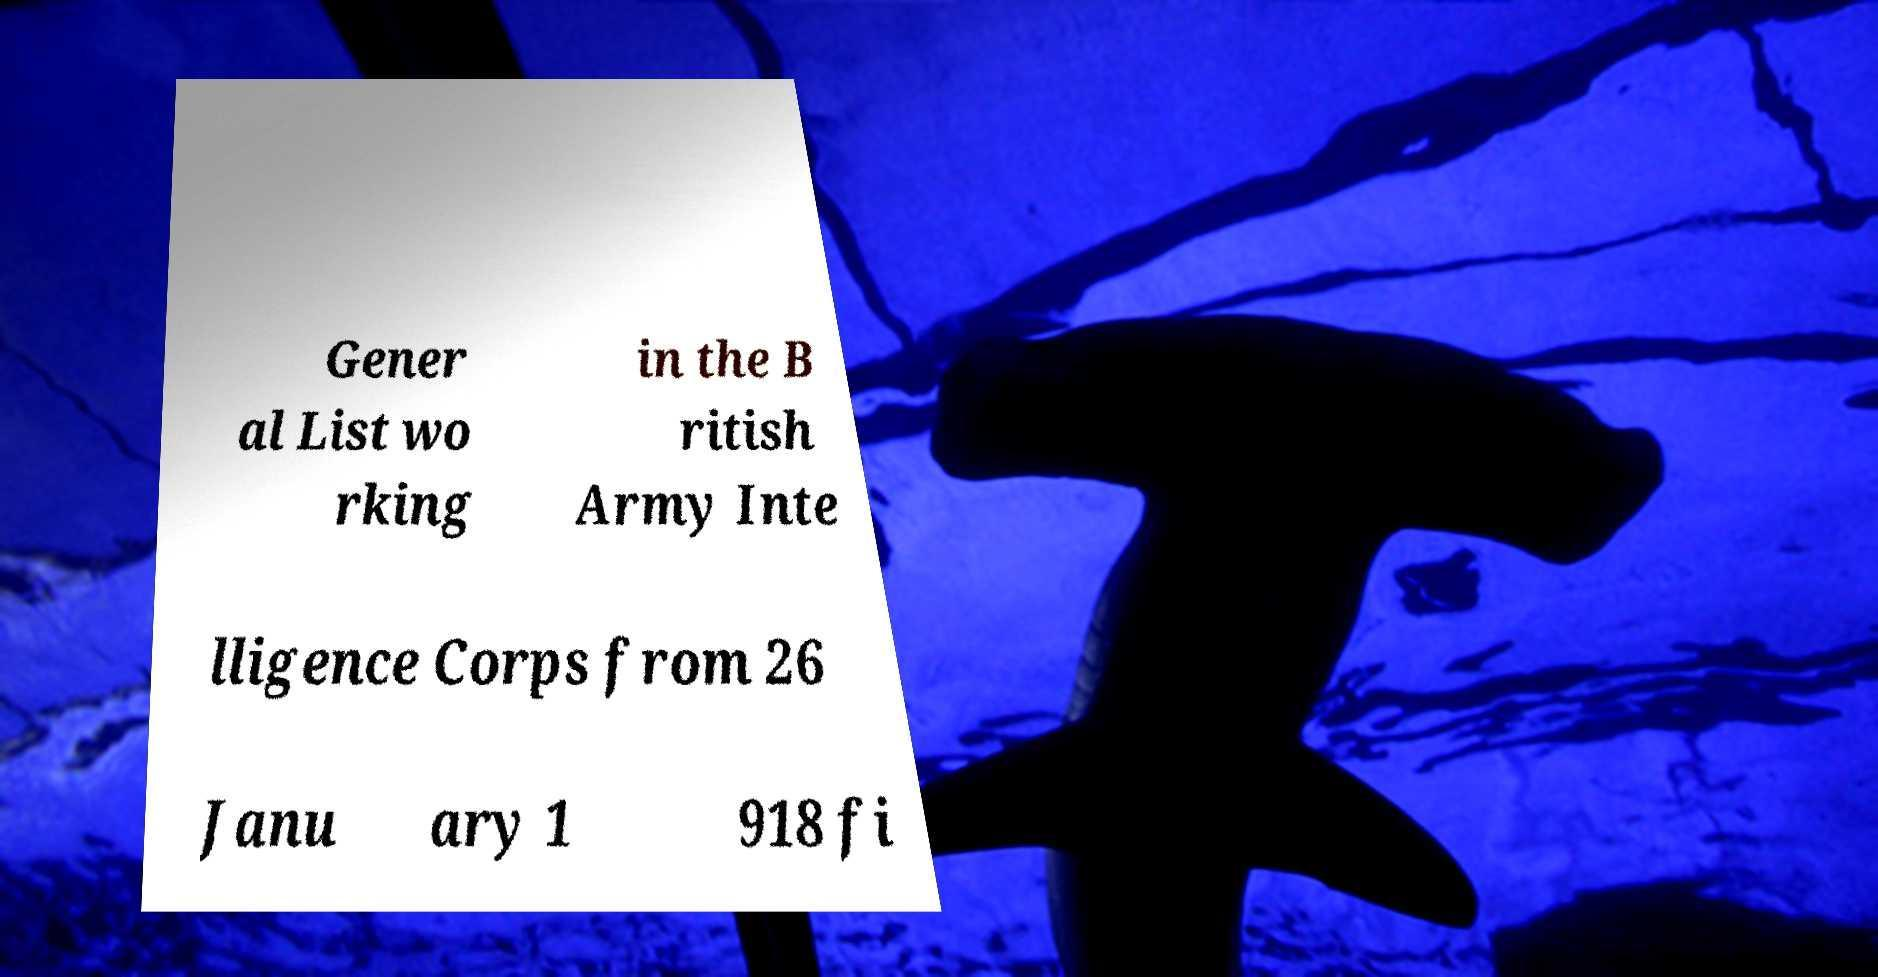Could you assist in decoding the text presented in this image and type it out clearly? Gener al List wo rking in the B ritish Army Inte lligence Corps from 26 Janu ary 1 918 fi 